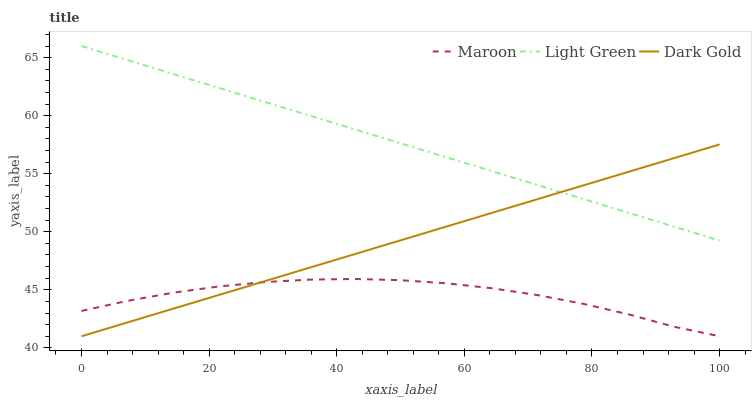Does Maroon have the minimum area under the curve?
Answer yes or no. Yes. Does Light Green have the maximum area under the curve?
Answer yes or no. Yes. Does Dark Gold have the minimum area under the curve?
Answer yes or no. No. Does Dark Gold have the maximum area under the curve?
Answer yes or no. No. Is Light Green the smoothest?
Answer yes or no. Yes. Is Maroon the roughest?
Answer yes or no. Yes. Is Dark Gold the smoothest?
Answer yes or no. No. Is Dark Gold the roughest?
Answer yes or no. No. Does Dark Gold have the highest value?
Answer yes or no. No. Is Maroon less than Light Green?
Answer yes or no. Yes. Is Light Green greater than Maroon?
Answer yes or no. Yes. Does Maroon intersect Light Green?
Answer yes or no. No. 